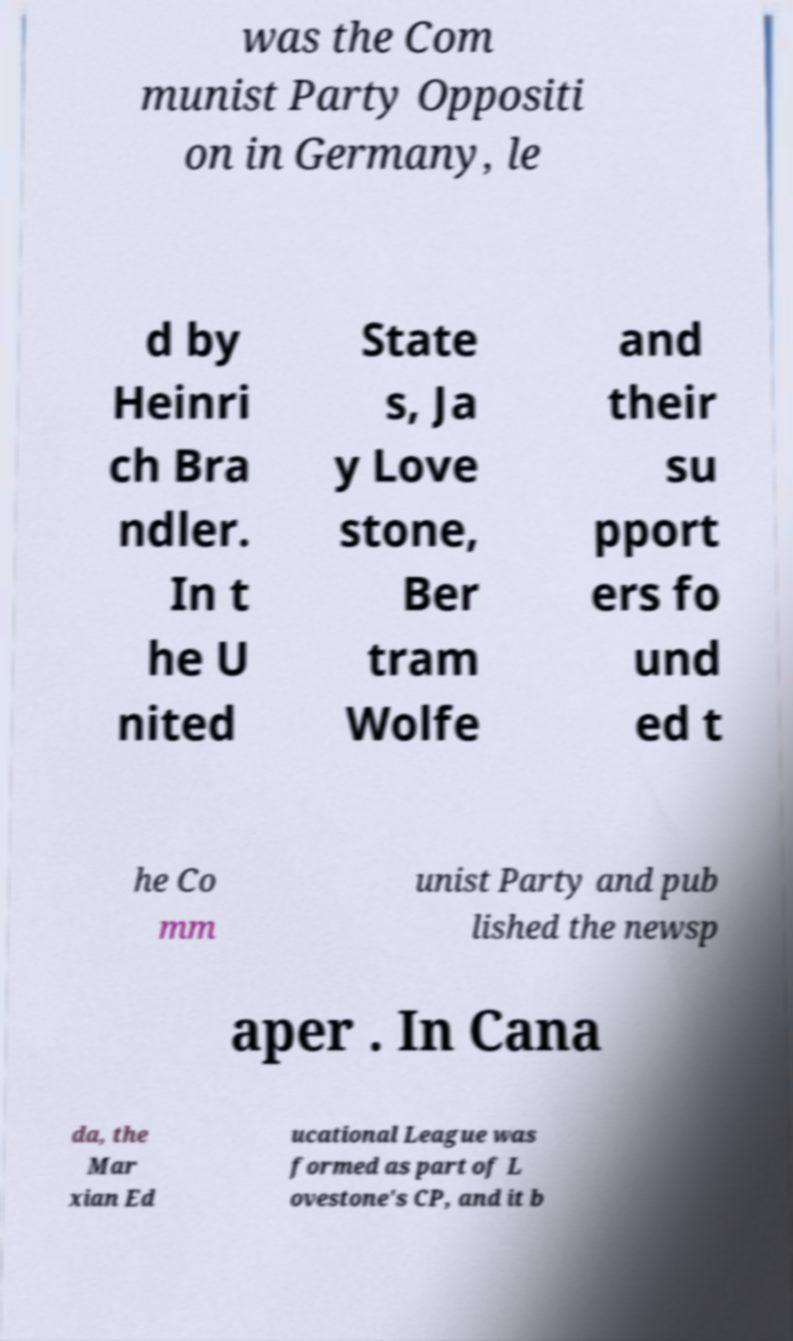Please identify and transcribe the text found in this image. was the Com munist Party Oppositi on in Germany, le d by Heinri ch Bra ndler. In t he U nited State s, Ja y Love stone, Ber tram Wolfe and their su pport ers fo und ed t he Co mm unist Party and pub lished the newsp aper . In Cana da, the Mar xian Ed ucational League was formed as part of L ovestone's CP, and it b 